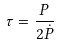Convert formula to latex. <formula><loc_0><loc_0><loc_500><loc_500>\tau = \frac { P } { 2 \dot { P } }</formula> 